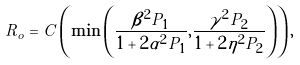Convert formula to latex. <formula><loc_0><loc_0><loc_500><loc_500>R _ { o } = C \left ( \min \left ( \frac { \beta ^ { 2 } P _ { 1 } } { 1 + 2 \alpha ^ { 2 } P _ { 1 } } , \frac { \gamma ^ { 2 } P _ { 2 } } { 1 + 2 \eta ^ { 2 } P _ { 2 } } \right ) \right ) ,</formula> 